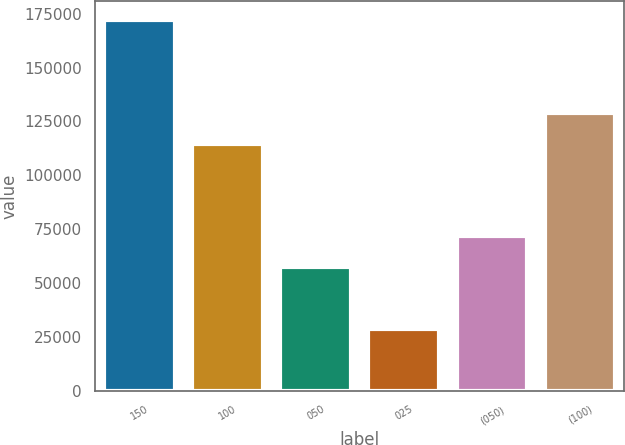Convert chart to OTSL. <chart><loc_0><loc_0><loc_500><loc_500><bar_chart><fcel>150<fcel>100<fcel>050<fcel>025<fcel>(050)<fcel>(100)<nl><fcel>172100<fcel>114700<fcel>57400<fcel>28700<fcel>71740<fcel>129040<nl></chart> 